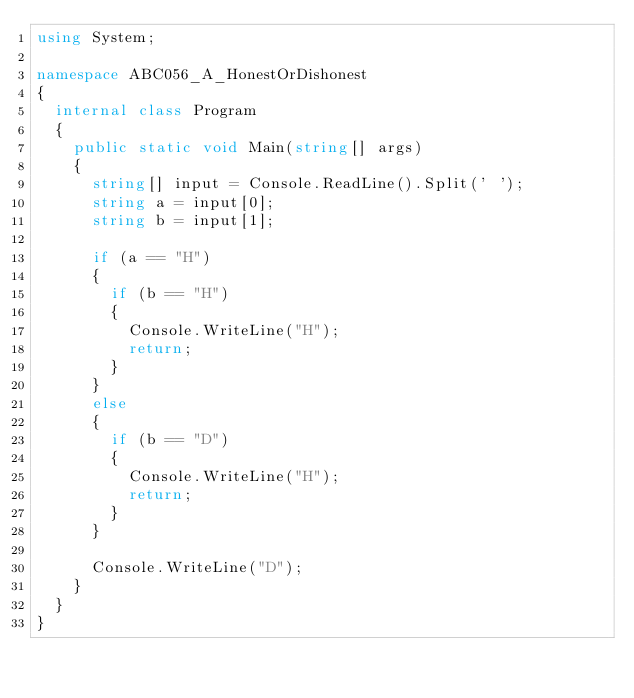Convert code to text. <code><loc_0><loc_0><loc_500><loc_500><_C#_>using System;

namespace ABC056_A_HonestOrDishonest
{
	internal class Program
	{
		public static void Main(string[] args)
		{
			string[] input = Console.ReadLine().Split(' ');
			string a = input[0];
			string b = input[1];

			if (a == "H")
			{
				if (b == "H")
				{
					Console.WriteLine("H");
					return;
				}
			}
			else
			{
				if (b == "D")
				{
					Console.WriteLine("H");
					return;
				}
			}
			
			Console.WriteLine("D");
		}
	}
}</code> 